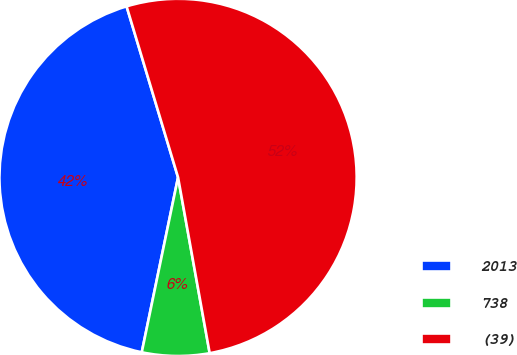Convert chart to OTSL. <chart><loc_0><loc_0><loc_500><loc_500><pie_chart><fcel>2013<fcel>738<fcel>(39)<nl><fcel>42.09%<fcel>6.09%<fcel>51.82%<nl></chart> 